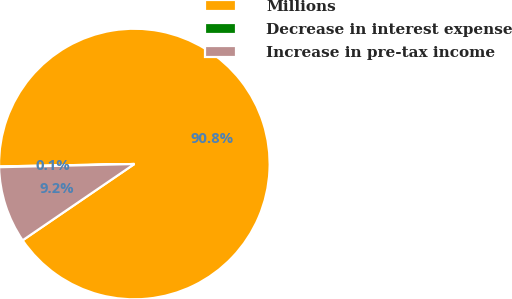Convert chart to OTSL. <chart><loc_0><loc_0><loc_500><loc_500><pie_chart><fcel>Millions<fcel>Decrease in interest expense<fcel>Increase in pre-tax income<nl><fcel>90.75%<fcel>0.09%<fcel>9.16%<nl></chart> 